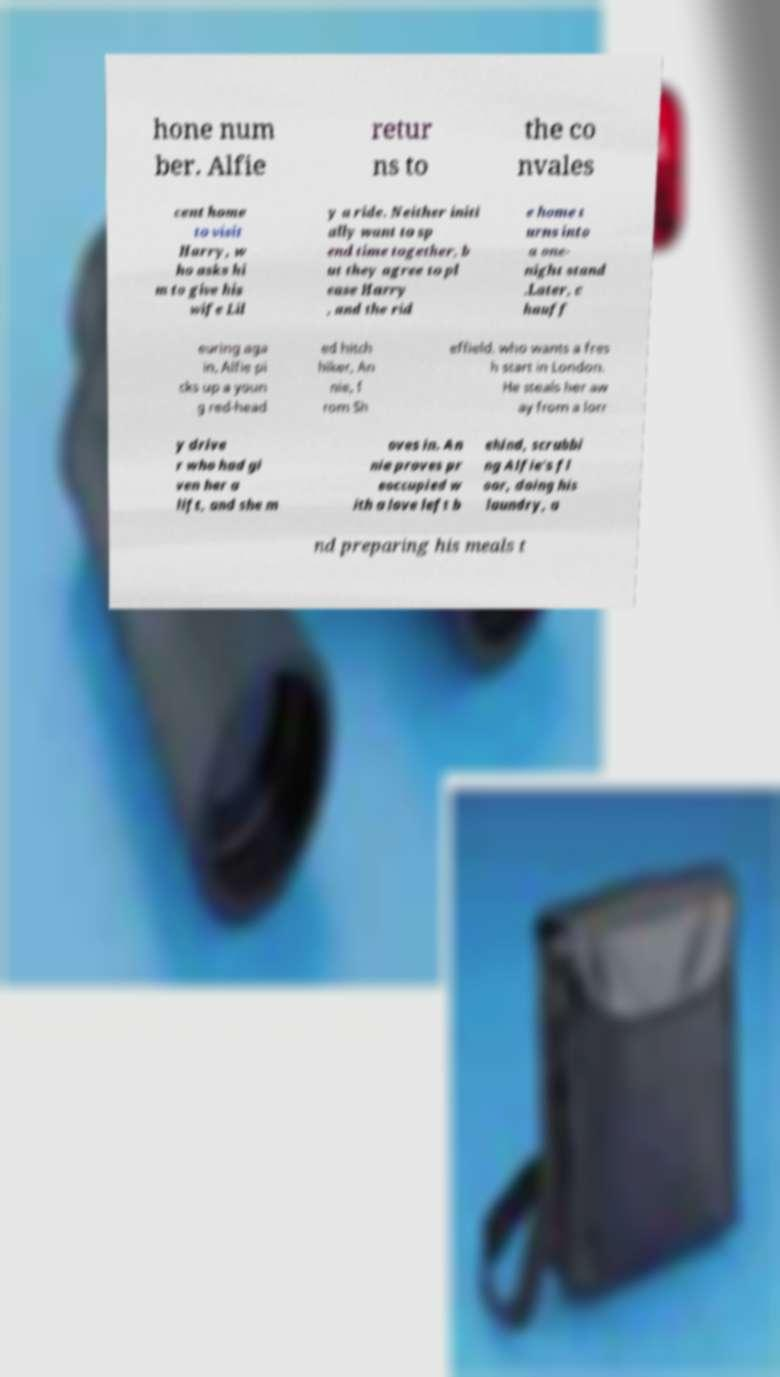Can you read and provide the text displayed in the image?This photo seems to have some interesting text. Can you extract and type it out for me? hone num ber. Alfie retur ns to the co nvales cent home to visit Harry, w ho asks hi m to give his wife Lil y a ride. Neither initi ally want to sp end time together, b ut they agree to pl ease Harry , and the rid e home t urns into a one- night stand .Later, c hauff euring aga in, Alfie pi cks up a youn g red-head ed hitch hiker, An nie, f rom Sh effield, who wants a fres h start in London. He steals her aw ay from a lorr y drive r who had gi ven her a lift, and she m oves in. An nie proves pr eoccupied w ith a love left b ehind, scrubbi ng Alfie's fl oor, doing his laundry, a nd preparing his meals t 